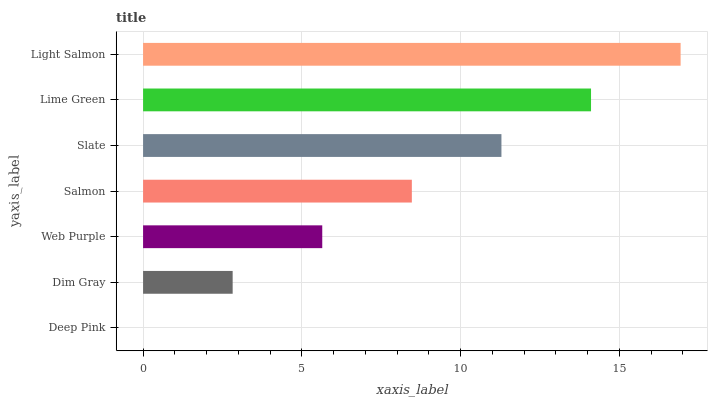Is Deep Pink the minimum?
Answer yes or no. Yes. Is Light Salmon the maximum?
Answer yes or no. Yes. Is Dim Gray the minimum?
Answer yes or no. No. Is Dim Gray the maximum?
Answer yes or no. No. Is Dim Gray greater than Deep Pink?
Answer yes or no. Yes. Is Deep Pink less than Dim Gray?
Answer yes or no. Yes. Is Deep Pink greater than Dim Gray?
Answer yes or no. No. Is Dim Gray less than Deep Pink?
Answer yes or no. No. Is Salmon the high median?
Answer yes or no. Yes. Is Salmon the low median?
Answer yes or no. Yes. Is Lime Green the high median?
Answer yes or no. No. Is Web Purple the low median?
Answer yes or no. No. 